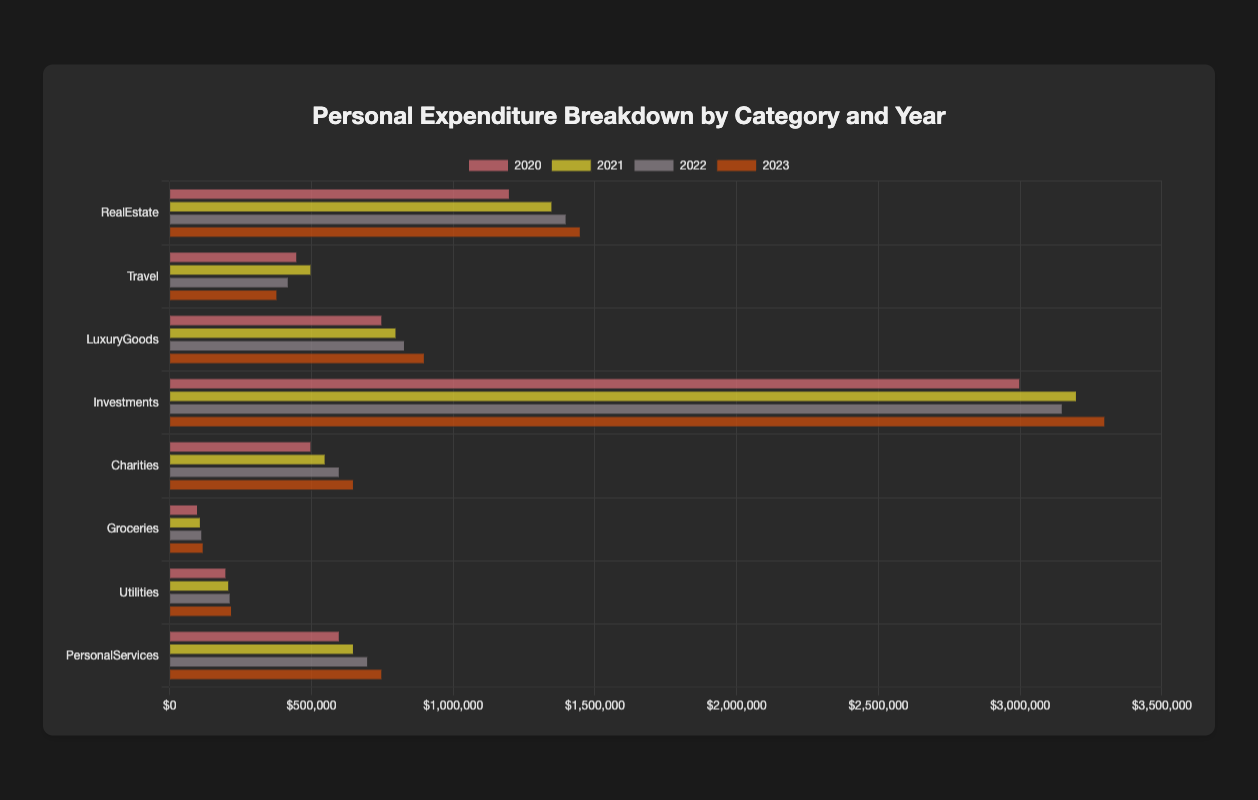Which year had the highest expenditure on Travel? By looking at the horizontal grouped bar chart, we can compare the lengths of the bars for the "Travel" category across different years. The longest bar for Travel corresponds to the year 2021.
Answer: 2021 What is the total expenditure on Travel across all years combined? To calculate the total expenditure on Travel, sum the values for Travel from each year: 450000 (2020) + 500000 (2021) + 420000 (2022) + 380000 (2023) = 1750000.
Answer: 1750000 Which category had the lowest expenditure in 2020? Check the heights of the bars for the year 2020 and identify the shortest bar, which corresponds to Groceries at 100000.
Answer: Groceries How much more was spent on Investments than on Charities in 2022? Subtract the expenditure on Charities from the expenditure on Investments for the year 2022: 3150000 (Investments) - 600000 (Charities) = 2550000.
Answer: 2550000 Which category showed the most consistent increase in expenditure from 2020 to 2023? By visually examining the trend in the heights of the bars for each category across the years, we see that RealEstate shows a consistent increase each year: 1200000 (2020), 1350000 (2021), 1400000 (2022), 1450000 (2023).
Answer: RealEstate What is the average yearly expenditure on LuxuryGoods between 2020 and 2023? To find the average, sum up the yearly expenditure for LuxuryGoods and divide by the number of years: (750000 (2020) + 800000 (2021) + 830000 (2022) + 900000 (2023)) / 4 = 3200000 / 4 = 800000.
Answer: 800000 Which category had the highest total expenditure over the 4 years combined? Sum the expenditures for each category over all four years and find the highest total. Investments has the highest total: 3000000 (2020) + 3200000 (2021) + 3150000 (2022) + 3300000 (2023) = 12600000.
Answer: Investments Did expenditure on Charities increase or decrease each year, and by how much? Calculate the change in expenditure on Charities from one year to the next: 2021: 550000 - 500000 = 50000 increase; 2022: 600000 - 550000 = 50000 increase; 2023: 650000 - 600000 = 50000 increase. Expenditure on Charities increased by 50000 every year.
Answer: Increased by 50000 each year 